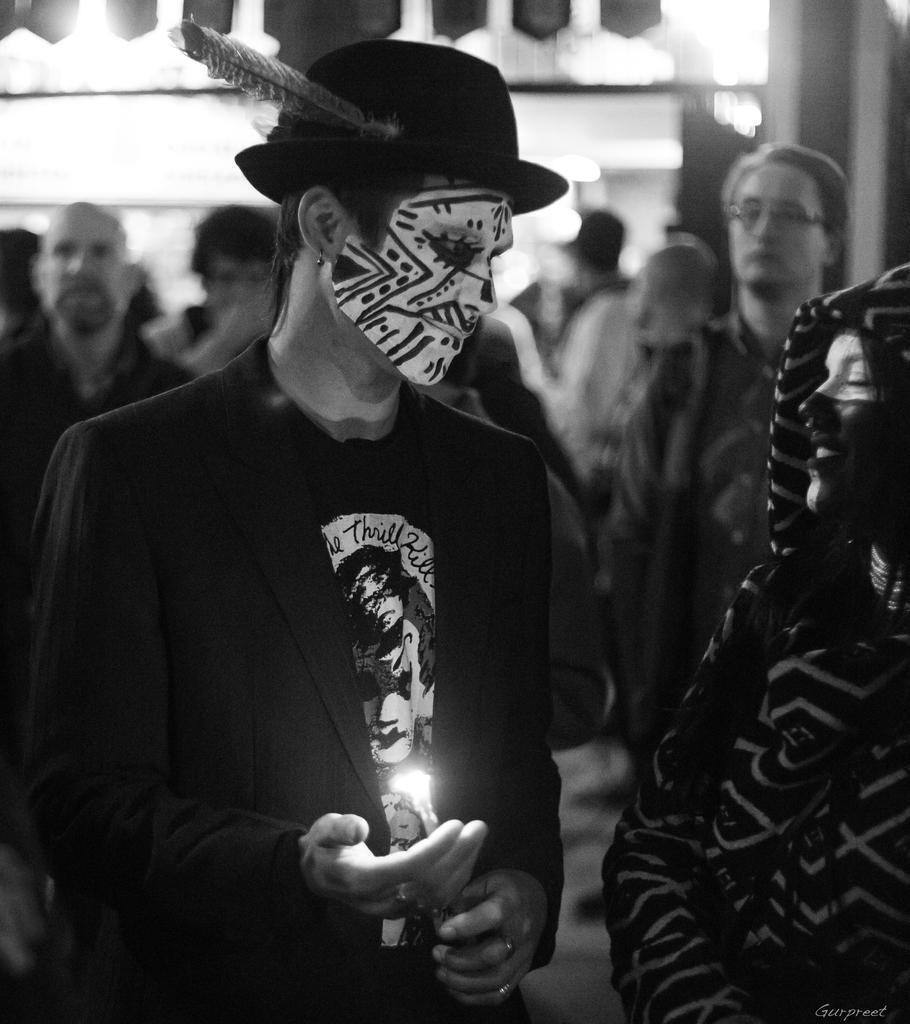Can you describe this image briefly? In this picture we can see two people with paintings on their faces, at the back of them we can see a group of people and in the background we can see some objects and it is blurry. 